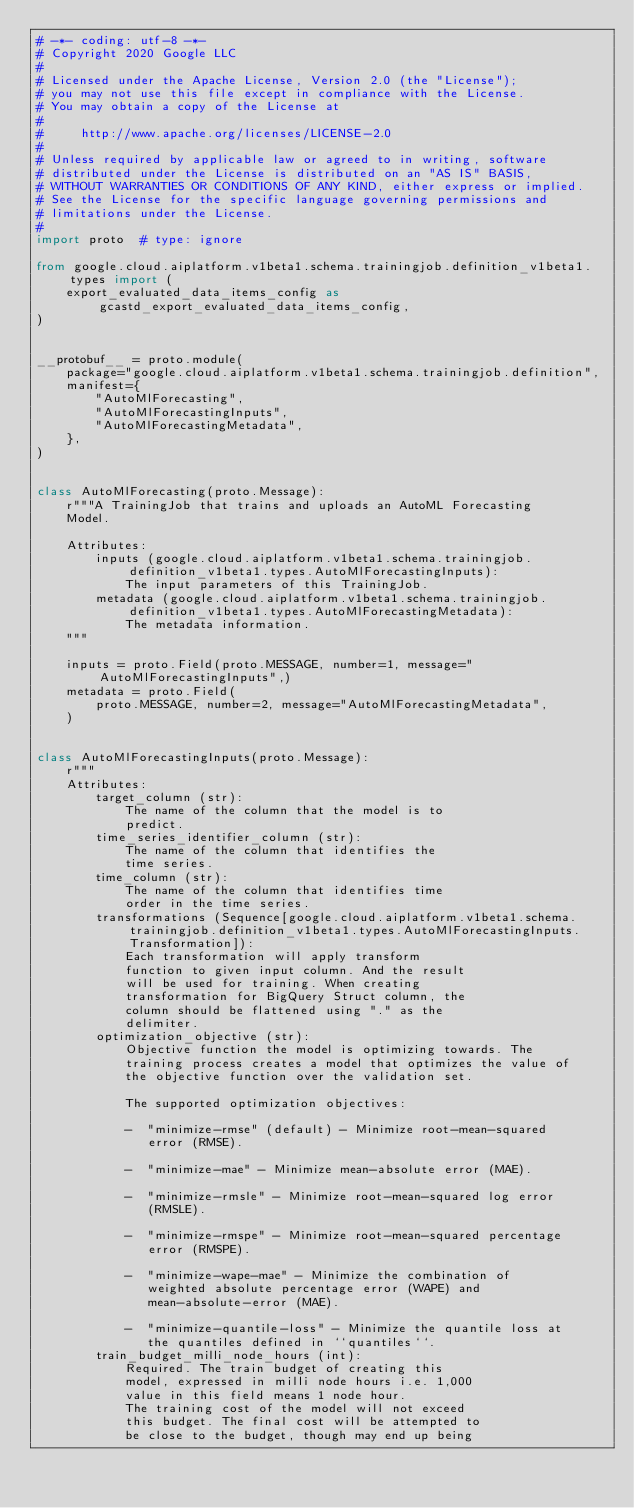<code> <loc_0><loc_0><loc_500><loc_500><_Python_># -*- coding: utf-8 -*-
# Copyright 2020 Google LLC
#
# Licensed under the Apache License, Version 2.0 (the "License");
# you may not use this file except in compliance with the License.
# You may obtain a copy of the License at
#
#     http://www.apache.org/licenses/LICENSE-2.0
#
# Unless required by applicable law or agreed to in writing, software
# distributed under the License is distributed on an "AS IS" BASIS,
# WITHOUT WARRANTIES OR CONDITIONS OF ANY KIND, either express or implied.
# See the License for the specific language governing permissions and
# limitations under the License.
#
import proto  # type: ignore

from google.cloud.aiplatform.v1beta1.schema.trainingjob.definition_v1beta1.types import (
    export_evaluated_data_items_config as gcastd_export_evaluated_data_items_config,
)


__protobuf__ = proto.module(
    package="google.cloud.aiplatform.v1beta1.schema.trainingjob.definition",
    manifest={
        "AutoMlForecasting",
        "AutoMlForecastingInputs",
        "AutoMlForecastingMetadata",
    },
)


class AutoMlForecasting(proto.Message):
    r"""A TrainingJob that trains and uploads an AutoML Forecasting
    Model.

    Attributes:
        inputs (google.cloud.aiplatform.v1beta1.schema.trainingjob.definition_v1beta1.types.AutoMlForecastingInputs):
            The input parameters of this TrainingJob.
        metadata (google.cloud.aiplatform.v1beta1.schema.trainingjob.definition_v1beta1.types.AutoMlForecastingMetadata):
            The metadata information.
    """

    inputs = proto.Field(proto.MESSAGE, number=1, message="AutoMlForecastingInputs",)
    metadata = proto.Field(
        proto.MESSAGE, number=2, message="AutoMlForecastingMetadata",
    )


class AutoMlForecastingInputs(proto.Message):
    r"""
    Attributes:
        target_column (str):
            The name of the column that the model is to
            predict.
        time_series_identifier_column (str):
            The name of the column that identifies the
            time series.
        time_column (str):
            The name of the column that identifies time
            order in the time series.
        transformations (Sequence[google.cloud.aiplatform.v1beta1.schema.trainingjob.definition_v1beta1.types.AutoMlForecastingInputs.Transformation]):
            Each transformation will apply transform
            function to given input column. And the result
            will be used for training. When creating
            transformation for BigQuery Struct column, the
            column should be flattened using "." as the
            delimiter.
        optimization_objective (str):
            Objective function the model is optimizing towards. The
            training process creates a model that optimizes the value of
            the objective function over the validation set.

            The supported optimization objectives:

            -  "minimize-rmse" (default) - Minimize root-mean-squared
               error (RMSE).

            -  "minimize-mae" - Minimize mean-absolute error (MAE).

            -  "minimize-rmsle" - Minimize root-mean-squared log error
               (RMSLE).

            -  "minimize-rmspe" - Minimize root-mean-squared percentage
               error (RMSPE).

            -  "minimize-wape-mae" - Minimize the combination of
               weighted absolute percentage error (WAPE) and
               mean-absolute-error (MAE).

            -  "minimize-quantile-loss" - Minimize the quantile loss at
               the quantiles defined in ``quantiles``.
        train_budget_milli_node_hours (int):
            Required. The train budget of creating this
            model, expressed in milli node hours i.e. 1,000
            value in this field means 1 node hour.
            The training cost of the model will not exceed
            this budget. The final cost will be attempted to
            be close to the budget, though may end up being</code> 